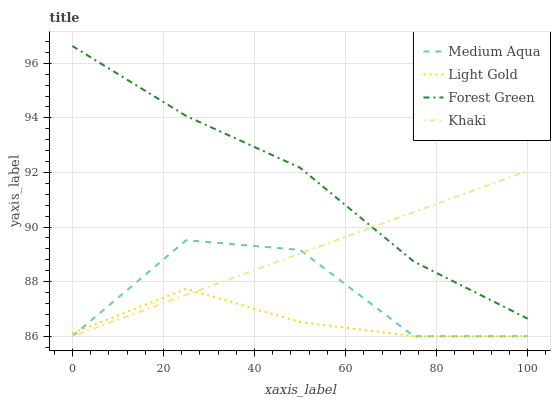Does Light Gold have the minimum area under the curve?
Answer yes or no. Yes. Does Forest Green have the maximum area under the curve?
Answer yes or no. Yes. Does Khaki have the minimum area under the curve?
Answer yes or no. No. Does Khaki have the maximum area under the curve?
Answer yes or no. No. Is Khaki the smoothest?
Answer yes or no. Yes. Is Medium Aqua the roughest?
Answer yes or no. Yes. Is Forest Green the smoothest?
Answer yes or no. No. Is Forest Green the roughest?
Answer yes or no. No. Does Forest Green have the lowest value?
Answer yes or no. No. Does Khaki have the highest value?
Answer yes or no. No. Is Medium Aqua less than Forest Green?
Answer yes or no. Yes. Is Forest Green greater than Light Gold?
Answer yes or no. Yes. Does Medium Aqua intersect Forest Green?
Answer yes or no. No. 